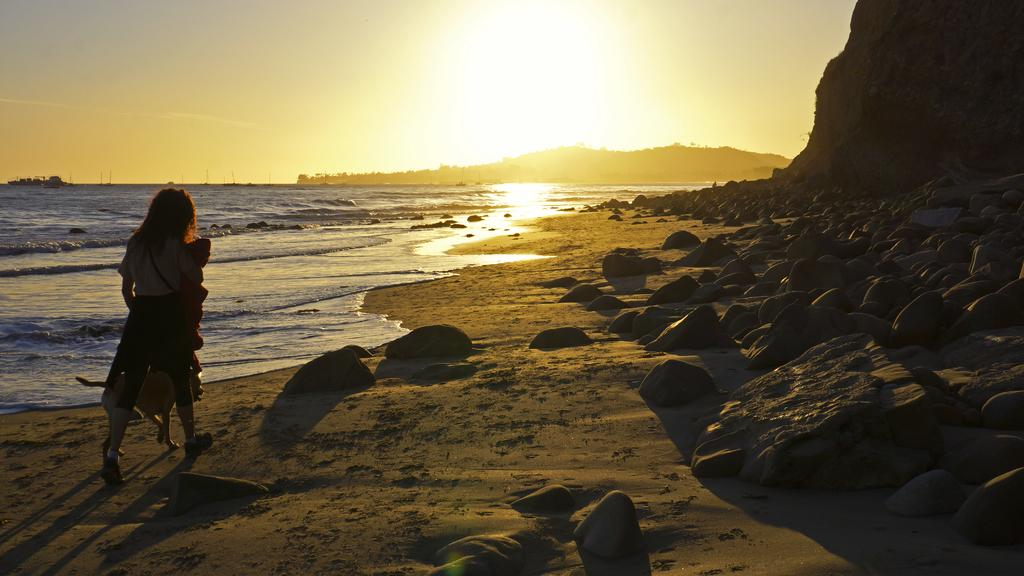What can be seen in the foreground of the image? There is a lady and a dog in the foreground of the image, along with some stones. What is the setting of the background in the image? The background of the image features a beach, mountains, stones, poles, and the sky. What type of ornament is the lady wearing on her ear in the image? There is no ornament visible on the lady's ear in the image. What discovery was made by the dog in the image? There is no indication of a discovery made by the dog in the image. 